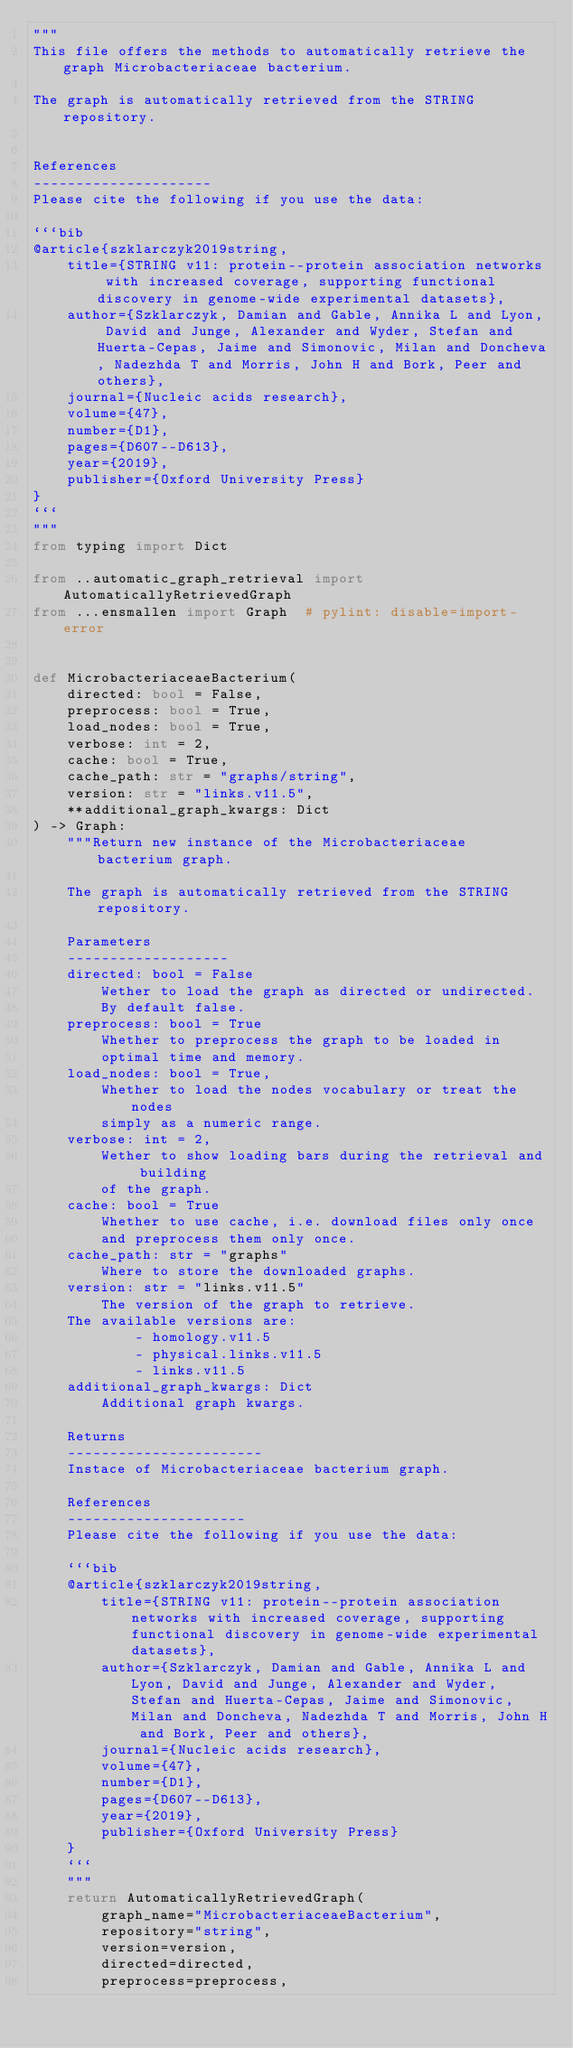<code> <loc_0><loc_0><loc_500><loc_500><_Python_>"""
This file offers the methods to automatically retrieve the graph Microbacteriaceae bacterium.

The graph is automatically retrieved from the STRING repository. 


References
---------------------
Please cite the following if you use the data:

```bib
@article{szklarczyk2019string,
    title={STRING v11: protein--protein association networks with increased coverage, supporting functional discovery in genome-wide experimental datasets},
    author={Szklarczyk, Damian and Gable, Annika L and Lyon, David and Junge, Alexander and Wyder, Stefan and Huerta-Cepas, Jaime and Simonovic, Milan and Doncheva, Nadezhda T and Morris, John H and Bork, Peer and others},
    journal={Nucleic acids research},
    volume={47},
    number={D1},
    pages={D607--D613},
    year={2019},
    publisher={Oxford University Press}
}
```
"""
from typing import Dict

from ..automatic_graph_retrieval import AutomaticallyRetrievedGraph
from ...ensmallen import Graph  # pylint: disable=import-error


def MicrobacteriaceaeBacterium(
    directed: bool = False,
    preprocess: bool = True,
    load_nodes: bool = True,
    verbose: int = 2,
    cache: bool = True,
    cache_path: str = "graphs/string",
    version: str = "links.v11.5",
    **additional_graph_kwargs: Dict
) -> Graph:
    """Return new instance of the Microbacteriaceae bacterium graph.

    The graph is automatically retrieved from the STRING repository.	

    Parameters
    -------------------
    directed: bool = False
        Wether to load the graph as directed or undirected.
        By default false.
    preprocess: bool = True
        Whether to preprocess the graph to be loaded in 
        optimal time and memory.
    load_nodes: bool = True,
        Whether to load the nodes vocabulary or treat the nodes
        simply as a numeric range.
    verbose: int = 2,
        Wether to show loading bars during the retrieval and building
        of the graph.
    cache: bool = True
        Whether to use cache, i.e. download files only once
        and preprocess them only once.
    cache_path: str = "graphs"
        Where to store the downloaded graphs.
    version: str = "links.v11.5"
        The version of the graph to retrieve.		
	The available versions are:
			- homology.v11.5
			- physical.links.v11.5
			- links.v11.5
    additional_graph_kwargs: Dict
        Additional graph kwargs.

    Returns
    -----------------------
    Instace of Microbacteriaceae bacterium graph.

	References
	---------------------
	Please cite the following if you use the data:
	
	```bib
	@article{szklarczyk2019string,
	    title={STRING v11: protein--protein association networks with increased coverage, supporting functional discovery in genome-wide experimental datasets},
	    author={Szklarczyk, Damian and Gable, Annika L and Lyon, David and Junge, Alexander and Wyder, Stefan and Huerta-Cepas, Jaime and Simonovic, Milan and Doncheva, Nadezhda T and Morris, John H and Bork, Peer and others},
	    journal={Nucleic acids research},
	    volume={47},
	    number={D1},
	    pages={D607--D613},
	    year={2019},
	    publisher={Oxford University Press}
	}
	```
    """
    return AutomaticallyRetrievedGraph(
        graph_name="MicrobacteriaceaeBacterium",
        repository="string",
        version=version,
        directed=directed,
        preprocess=preprocess,</code> 